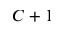<formula> <loc_0><loc_0><loc_500><loc_500>C + 1</formula> 